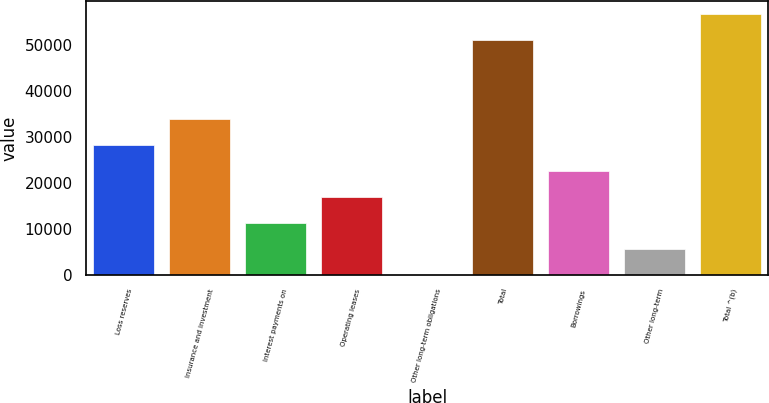Convert chart to OTSL. <chart><loc_0><loc_0><loc_500><loc_500><bar_chart><fcel>Loss reserves<fcel>Insurance and investment<fcel>Interest payments on<fcel>Operating leases<fcel>Other long-term obligations<fcel>Total<fcel>Borrowings<fcel>Other long-term<fcel>Total ^(b)<nl><fcel>28157<fcel>33787.6<fcel>11265.2<fcel>16895.8<fcel>4<fcel>51072<fcel>22526.4<fcel>5634.6<fcel>56702.6<nl></chart> 